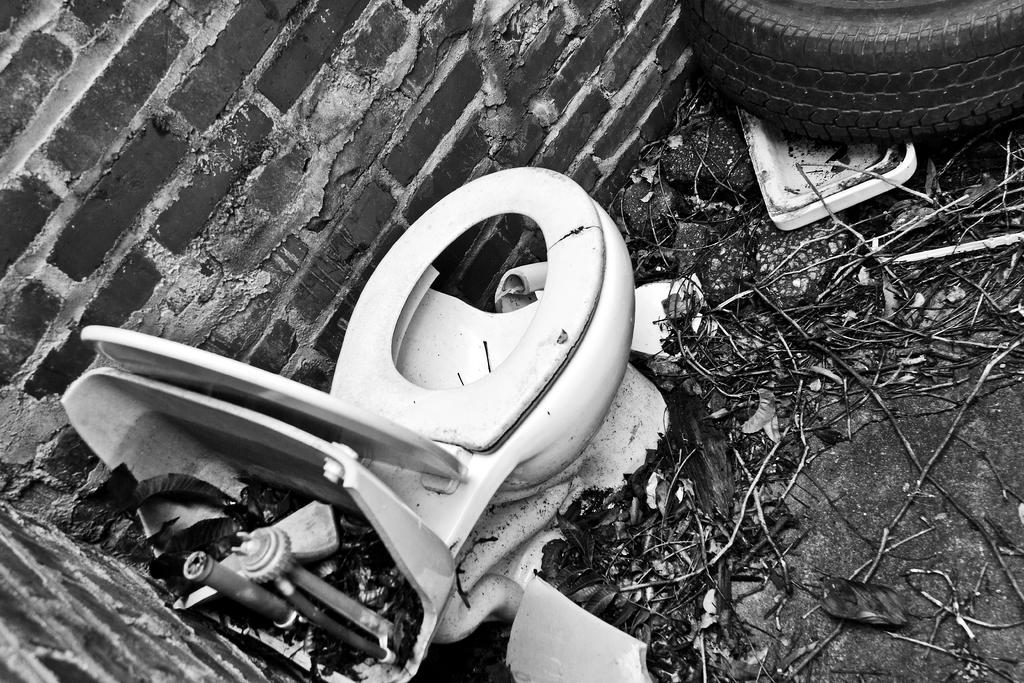What type of picture is in the image? The image contains a black and white picture. What objects can be seen in the black and white picture? There is a toilet seat, a tyre, and sticks in the black and white picture. What is on the ground in the black and white picture? There are leaves on the ground in the black and white picture. What material is the wall made of in the black and white picture? The wall in the black and white picture is made up of bricks. What is the income of the person who owns the pocket in the image? There is no pocket or reference to income in the image; it contains a black and white picture with various objects and elements. What type of plants can be seen growing in the image? There are no plants visible in the image; it features a black and white picture with a toilet seat, tyre, sticks, leaves, and bricks. 